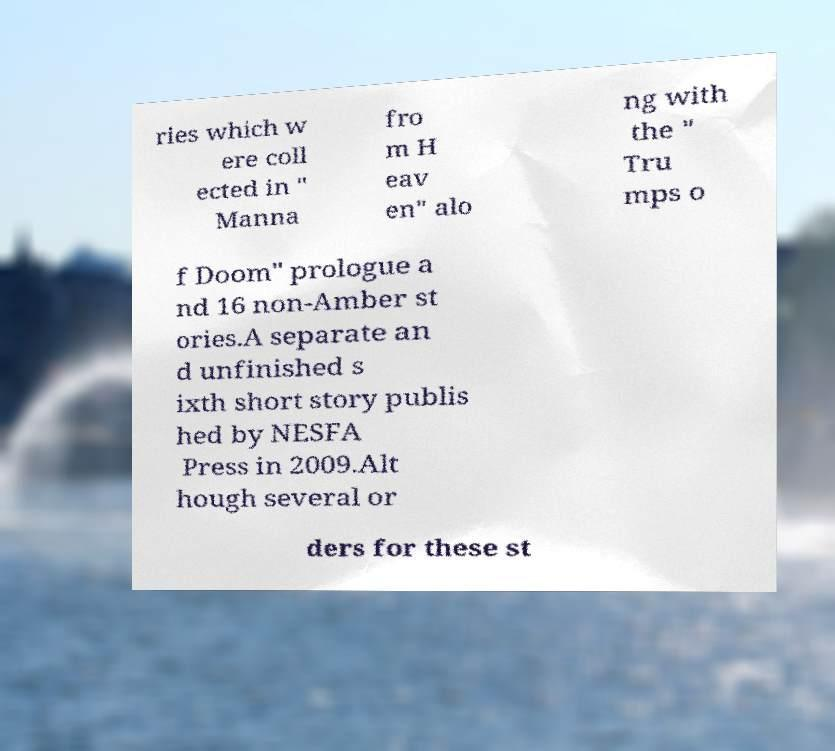Could you assist in decoding the text presented in this image and type it out clearly? ries which w ere coll ected in " Manna fro m H eav en" alo ng with the " Tru mps o f Doom" prologue a nd 16 non-Amber st ories.A separate an d unfinished s ixth short story publis hed by NESFA Press in 2009.Alt hough several or ders for these st 